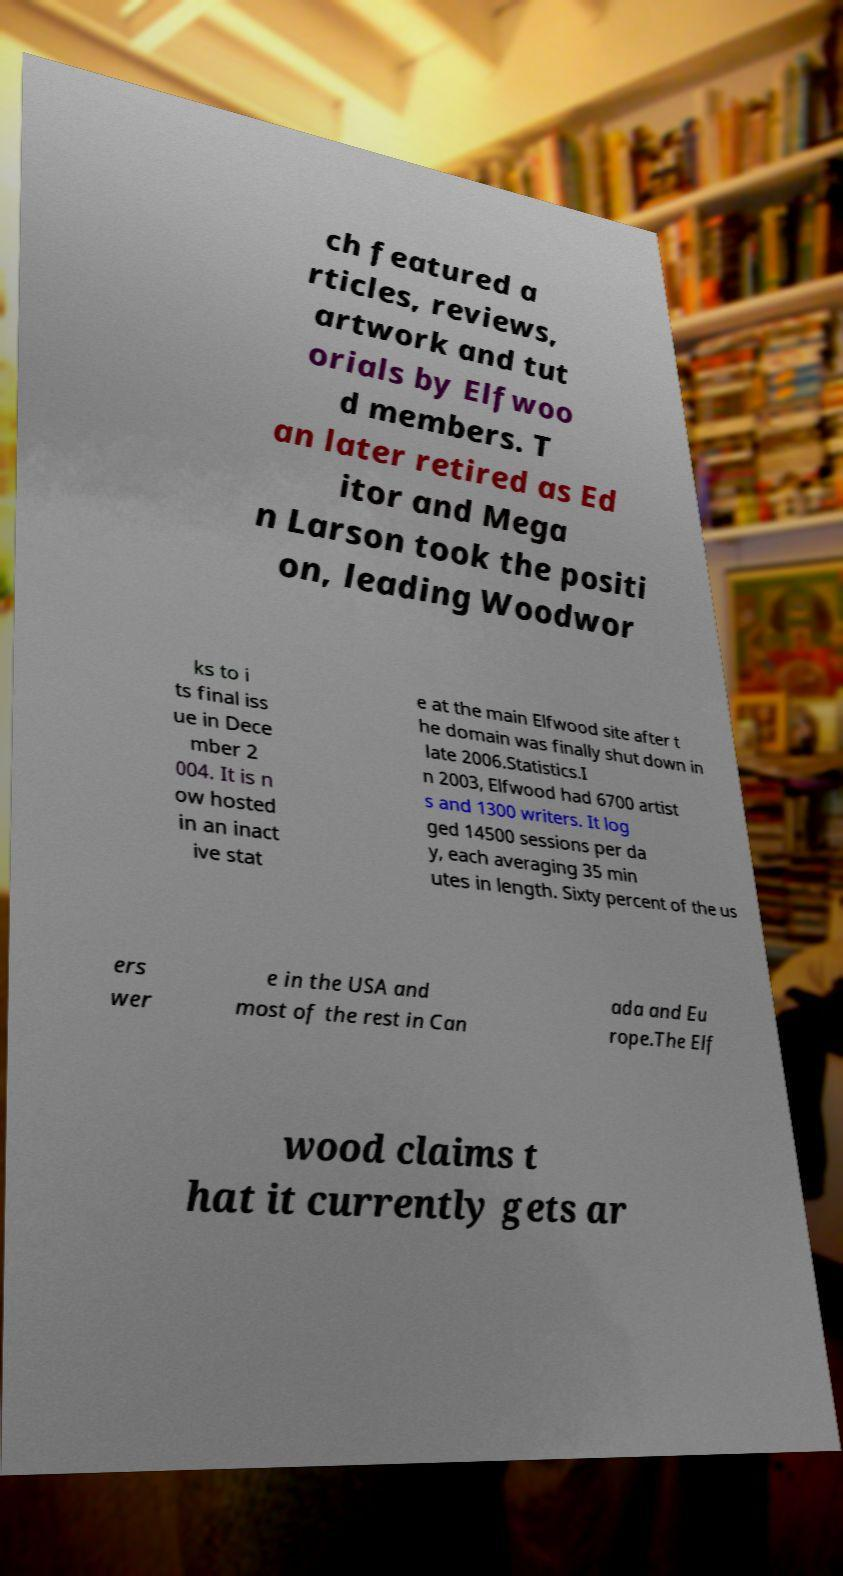Could you assist in decoding the text presented in this image and type it out clearly? ch featured a rticles, reviews, artwork and tut orials by Elfwoo d members. T an later retired as Ed itor and Mega n Larson took the positi on, leading Woodwor ks to i ts final iss ue in Dece mber 2 004. It is n ow hosted in an inact ive stat e at the main Elfwood site after t he domain was finally shut down in late 2006.Statistics.I n 2003, Elfwood had 6700 artist s and 1300 writers. It log ged 14500 sessions per da y, each averaging 35 min utes in length. Sixty percent of the us ers wer e in the USA and most of the rest in Can ada and Eu rope.The Elf wood claims t hat it currently gets ar 